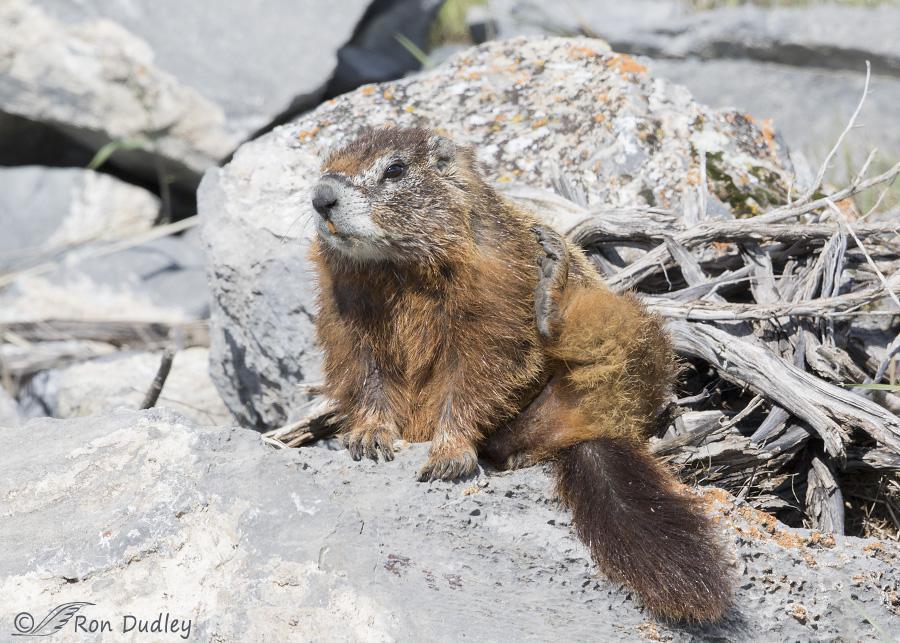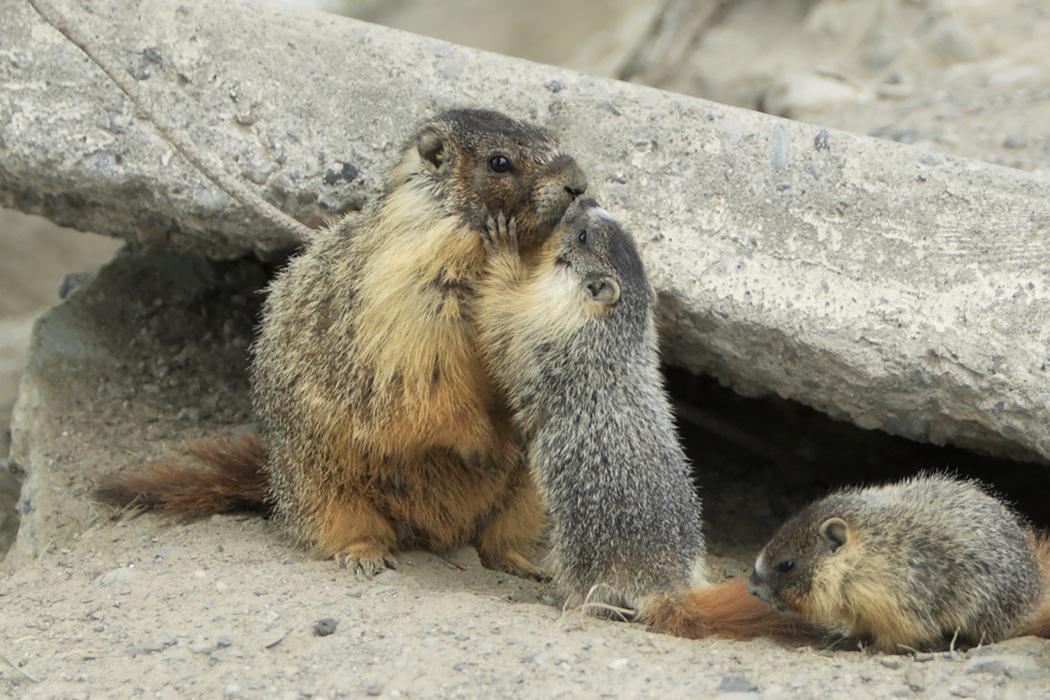The first image is the image on the left, the second image is the image on the right. Evaluate the accuracy of this statement regarding the images: "There are three animals near the rocks.". Is it true? Answer yes or no. Yes. 